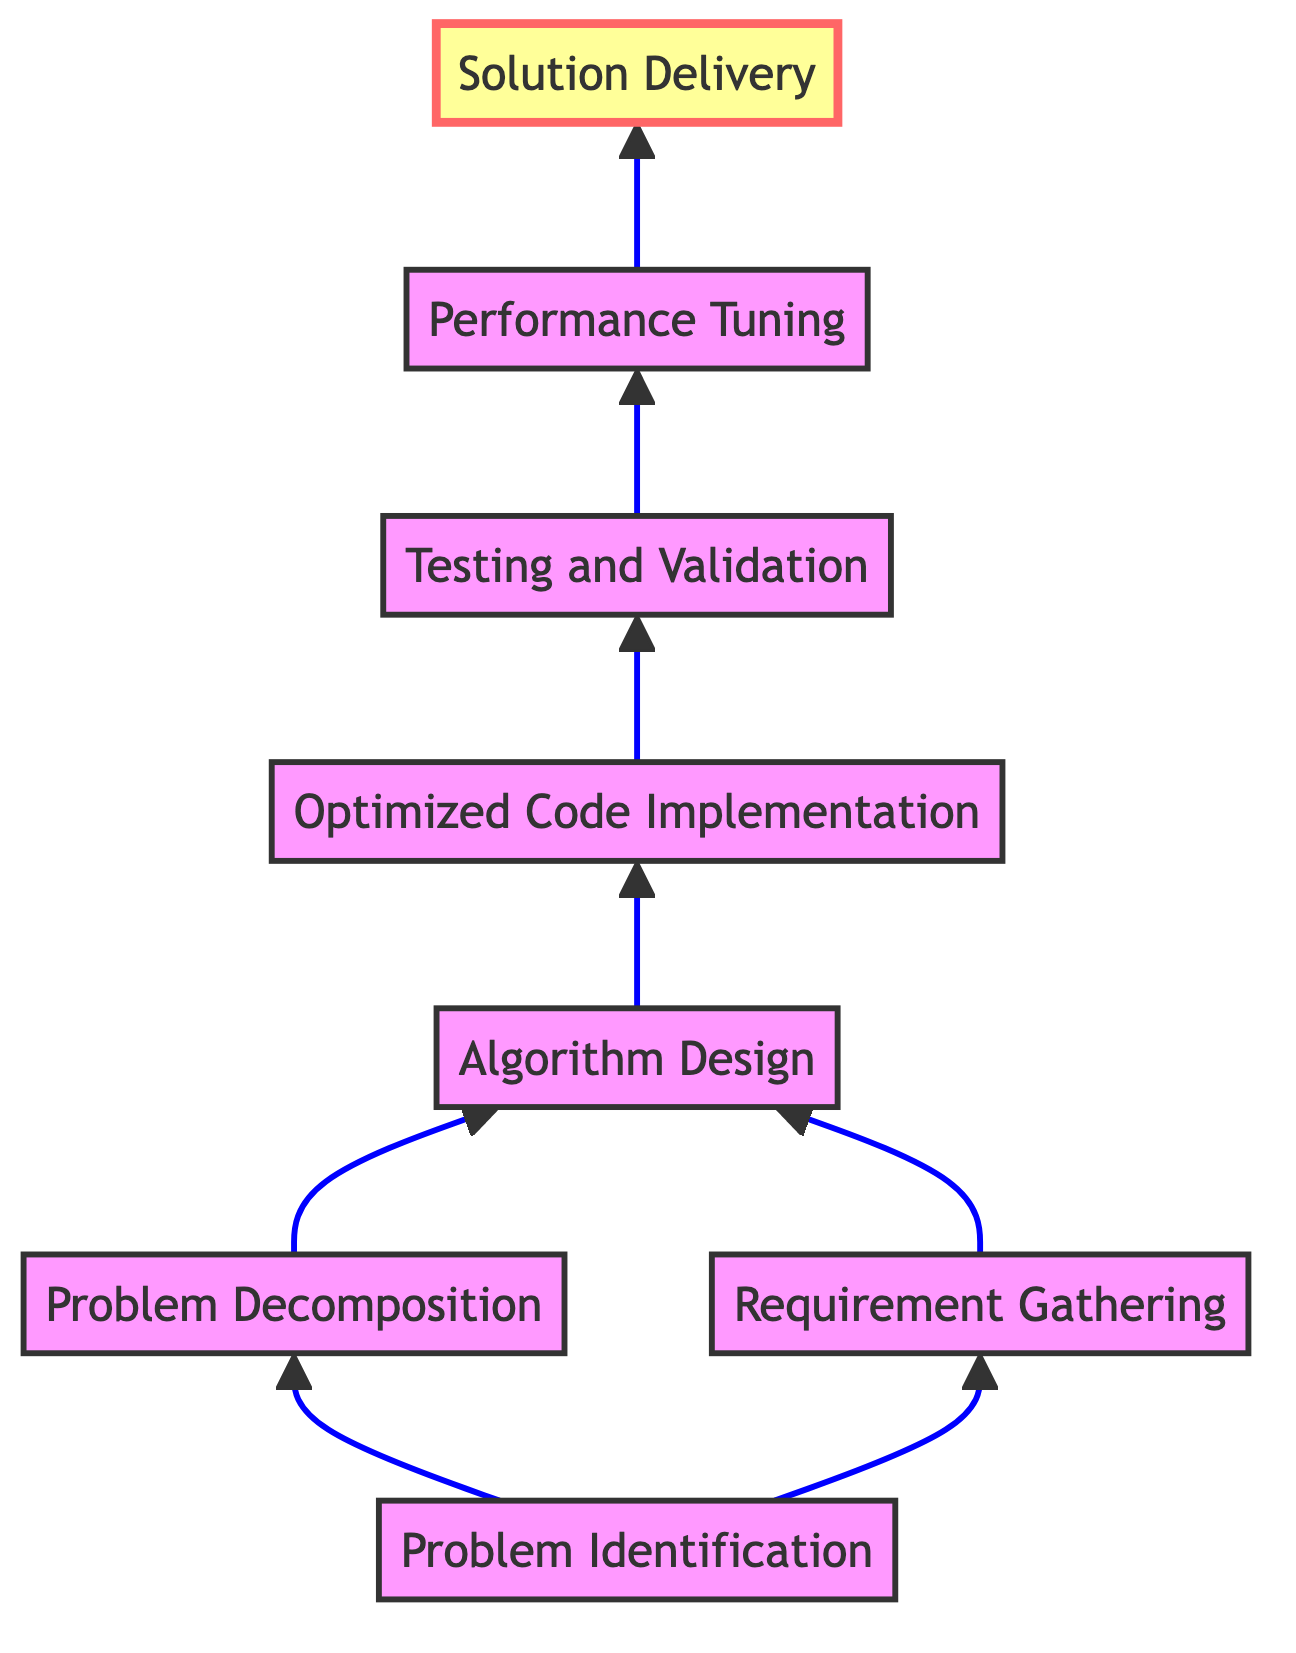What is the first step in the diagram? The first step is "Problem Identification," which is the first node that does not depend on any previous step.
Answer: Problem Identification How many total steps are there in the flowchart? There are eight steps in total, as represented by the eight nodes listed in the diagram.
Answer: Eight What step comes immediately after "Optimized Code Implementation"? The step that comes immediately after "Optimized Code Implementation" is "Testing and Validation," since it directly follows that node in the flow.
Answer: Testing and Validation Which two steps are dependent on "Problem Identification"? The two steps that depend on "Problem Identification" are "Problem Decomposition" and "Requirement Gathering." Both these steps directly receive input from this initial node.
Answer: Problem Decomposition, Requirement Gathering What is the last step before "Solution Delivery"? The last step before "Solution Delivery" is "Performance Tuning," as it directly feeds into the final solution phase of the process.
Answer: Performance Tuning Which step combines inputs from both "Problem Decomposition" and "Requirement Gathering"? The step that combines inputs from both "Problem Decomposition" and "Requirement Gathering" is "Algorithm Design," which requires data from both preceding nodes.
Answer: Algorithm Design How many steps must be completed before reaching "Solution Delivery"? To reach "Solution Delivery," seven steps must be completed, as it comes at the end of the process after all previous steps.
Answer: Seven What is the role of "Testing and Validation" in the flowchart? "Testing and Validation" plays a crucial role by ensuring the implemented code works correctly against various scenarios. It checks the output of the previous step.
Answer: Ensure correctness 